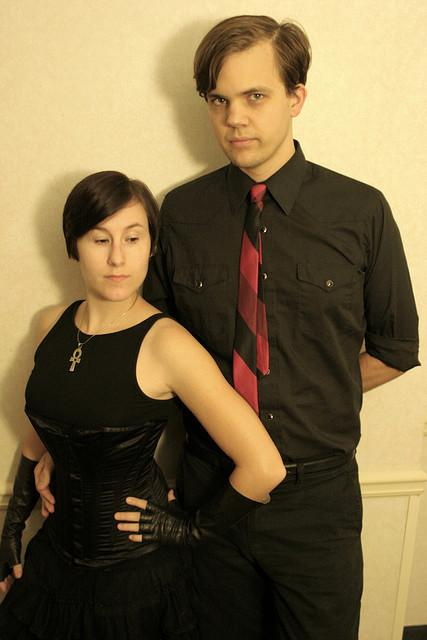What's the name of the pendant on the woman's necklace? ankh 